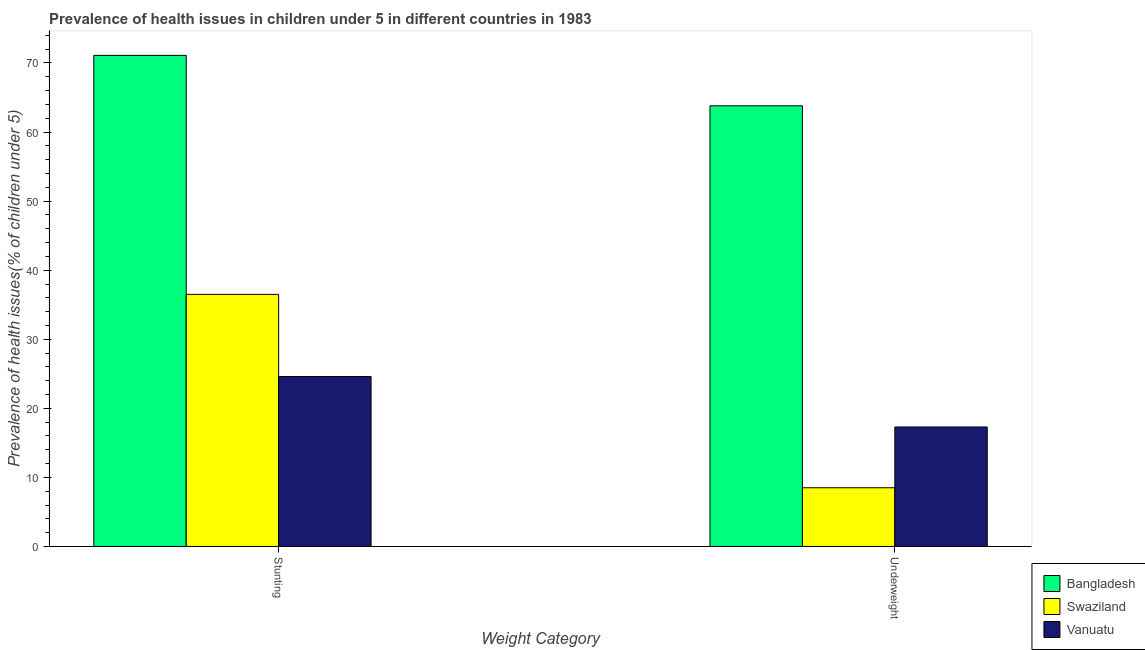How many bars are there on the 1st tick from the right?
Your response must be concise. 3. What is the label of the 2nd group of bars from the left?
Make the answer very short. Underweight. What is the percentage of stunted children in Vanuatu?
Keep it short and to the point. 24.6. Across all countries, what is the maximum percentage of underweight children?
Make the answer very short. 63.8. Across all countries, what is the minimum percentage of stunted children?
Give a very brief answer. 24.6. In which country was the percentage of stunted children minimum?
Your answer should be very brief. Vanuatu. What is the total percentage of stunted children in the graph?
Provide a short and direct response. 132.2. What is the difference between the percentage of stunted children in Vanuatu and that in Swaziland?
Your answer should be very brief. -11.9. What is the difference between the percentage of stunted children in Bangladesh and the percentage of underweight children in Swaziland?
Your response must be concise. 62.6. What is the average percentage of stunted children per country?
Provide a succinct answer. 44.07. What is the difference between the percentage of stunted children and percentage of underweight children in Bangladesh?
Give a very brief answer. 7.3. What is the ratio of the percentage of underweight children in Swaziland to that in Vanuatu?
Provide a succinct answer. 0.49. Is the percentage of underweight children in Swaziland less than that in Bangladesh?
Offer a very short reply. Yes. In how many countries, is the percentage of stunted children greater than the average percentage of stunted children taken over all countries?
Offer a very short reply. 1. What does the 1st bar from the left in Stunting represents?
Offer a very short reply. Bangladesh. How many bars are there?
Ensure brevity in your answer.  6. Are all the bars in the graph horizontal?
Your answer should be very brief. No. Where does the legend appear in the graph?
Ensure brevity in your answer.  Bottom right. How are the legend labels stacked?
Keep it short and to the point. Vertical. What is the title of the graph?
Your answer should be compact. Prevalence of health issues in children under 5 in different countries in 1983. What is the label or title of the X-axis?
Give a very brief answer. Weight Category. What is the label or title of the Y-axis?
Provide a short and direct response. Prevalence of health issues(% of children under 5). What is the Prevalence of health issues(% of children under 5) of Bangladesh in Stunting?
Provide a succinct answer. 71.1. What is the Prevalence of health issues(% of children under 5) in Swaziland in Stunting?
Make the answer very short. 36.5. What is the Prevalence of health issues(% of children under 5) of Vanuatu in Stunting?
Provide a succinct answer. 24.6. What is the Prevalence of health issues(% of children under 5) of Bangladesh in Underweight?
Provide a succinct answer. 63.8. What is the Prevalence of health issues(% of children under 5) in Swaziland in Underweight?
Offer a very short reply. 8.5. What is the Prevalence of health issues(% of children under 5) in Vanuatu in Underweight?
Provide a short and direct response. 17.3. Across all Weight Category, what is the maximum Prevalence of health issues(% of children under 5) of Bangladesh?
Your answer should be compact. 71.1. Across all Weight Category, what is the maximum Prevalence of health issues(% of children under 5) in Swaziland?
Offer a very short reply. 36.5. Across all Weight Category, what is the maximum Prevalence of health issues(% of children under 5) of Vanuatu?
Your answer should be compact. 24.6. Across all Weight Category, what is the minimum Prevalence of health issues(% of children under 5) in Bangladesh?
Provide a succinct answer. 63.8. Across all Weight Category, what is the minimum Prevalence of health issues(% of children under 5) in Swaziland?
Your response must be concise. 8.5. Across all Weight Category, what is the minimum Prevalence of health issues(% of children under 5) of Vanuatu?
Your response must be concise. 17.3. What is the total Prevalence of health issues(% of children under 5) of Bangladesh in the graph?
Provide a succinct answer. 134.9. What is the total Prevalence of health issues(% of children under 5) in Swaziland in the graph?
Keep it short and to the point. 45. What is the total Prevalence of health issues(% of children under 5) of Vanuatu in the graph?
Keep it short and to the point. 41.9. What is the difference between the Prevalence of health issues(% of children under 5) of Swaziland in Stunting and that in Underweight?
Provide a succinct answer. 28. What is the difference between the Prevalence of health issues(% of children under 5) of Vanuatu in Stunting and that in Underweight?
Offer a very short reply. 7.3. What is the difference between the Prevalence of health issues(% of children under 5) of Bangladesh in Stunting and the Prevalence of health issues(% of children under 5) of Swaziland in Underweight?
Provide a short and direct response. 62.6. What is the difference between the Prevalence of health issues(% of children under 5) in Bangladesh in Stunting and the Prevalence of health issues(% of children under 5) in Vanuatu in Underweight?
Give a very brief answer. 53.8. What is the difference between the Prevalence of health issues(% of children under 5) of Swaziland in Stunting and the Prevalence of health issues(% of children under 5) of Vanuatu in Underweight?
Offer a very short reply. 19.2. What is the average Prevalence of health issues(% of children under 5) of Bangladesh per Weight Category?
Make the answer very short. 67.45. What is the average Prevalence of health issues(% of children under 5) of Swaziland per Weight Category?
Your response must be concise. 22.5. What is the average Prevalence of health issues(% of children under 5) of Vanuatu per Weight Category?
Give a very brief answer. 20.95. What is the difference between the Prevalence of health issues(% of children under 5) of Bangladesh and Prevalence of health issues(% of children under 5) of Swaziland in Stunting?
Your response must be concise. 34.6. What is the difference between the Prevalence of health issues(% of children under 5) of Bangladesh and Prevalence of health issues(% of children under 5) of Vanuatu in Stunting?
Your response must be concise. 46.5. What is the difference between the Prevalence of health issues(% of children under 5) in Bangladesh and Prevalence of health issues(% of children under 5) in Swaziland in Underweight?
Offer a terse response. 55.3. What is the difference between the Prevalence of health issues(% of children under 5) of Bangladesh and Prevalence of health issues(% of children under 5) of Vanuatu in Underweight?
Provide a succinct answer. 46.5. What is the ratio of the Prevalence of health issues(% of children under 5) of Bangladesh in Stunting to that in Underweight?
Give a very brief answer. 1.11. What is the ratio of the Prevalence of health issues(% of children under 5) of Swaziland in Stunting to that in Underweight?
Provide a short and direct response. 4.29. What is the ratio of the Prevalence of health issues(% of children under 5) in Vanuatu in Stunting to that in Underweight?
Offer a very short reply. 1.42. What is the difference between the highest and the second highest Prevalence of health issues(% of children under 5) of Swaziland?
Ensure brevity in your answer.  28. What is the difference between the highest and the lowest Prevalence of health issues(% of children under 5) in Bangladesh?
Offer a very short reply. 7.3. What is the difference between the highest and the lowest Prevalence of health issues(% of children under 5) in Vanuatu?
Provide a short and direct response. 7.3. 